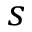Convert formula to latex. <formula><loc_0><loc_0><loc_500><loc_500>s</formula> 